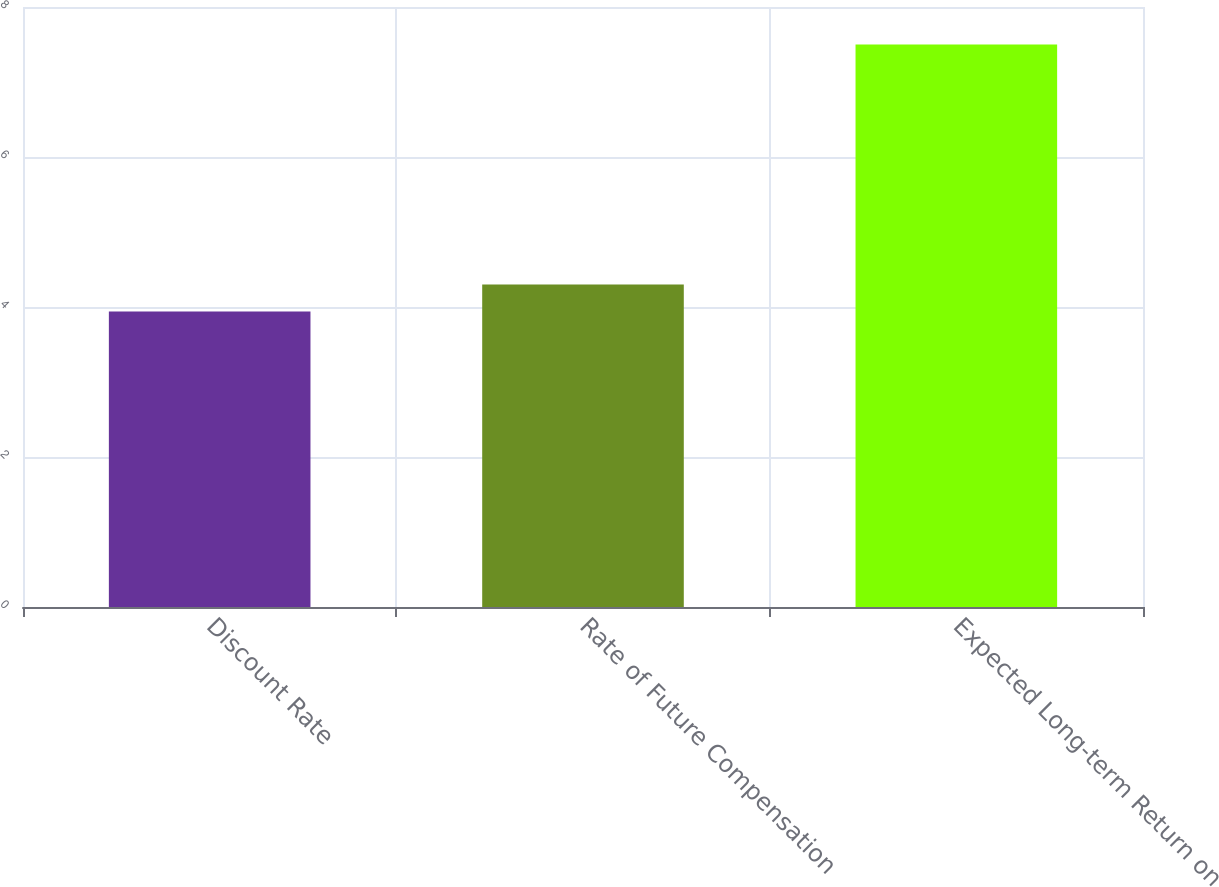Convert chart. <chart><loc_0><loc_0><loc_500><loc_500><bar_chart><fcel>Discount Rate<fcel>Rate of Future Compensation<fcel>Expected Long-term Return on<nl><fcel>3.94<fcel>4.3<fcel>7.5<nl></chart> 